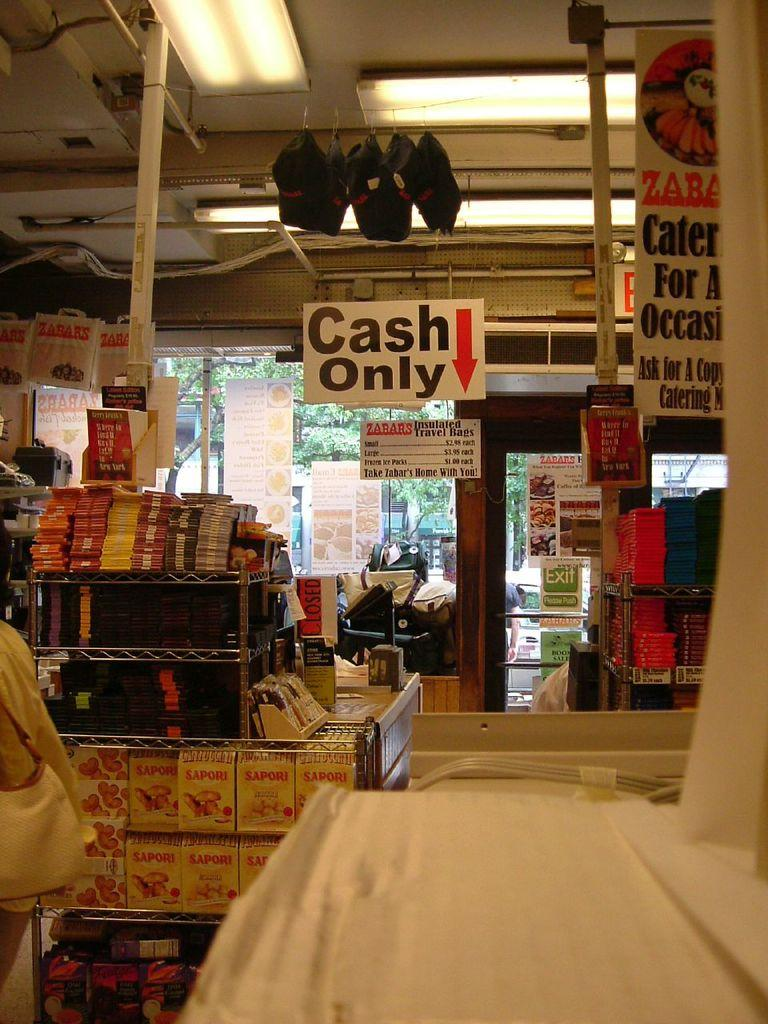<image>
Write a terse but informative summary of the picture. A store that only accepts cash from customers. 